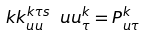<formula> <loc_0><loc_0><loc_500><loc_500>\ k k _ { u u } ^ { k \tau s } \ u u _ { \tau } ^ { k } = P _ { u \tau } ^ { k }</formula> 